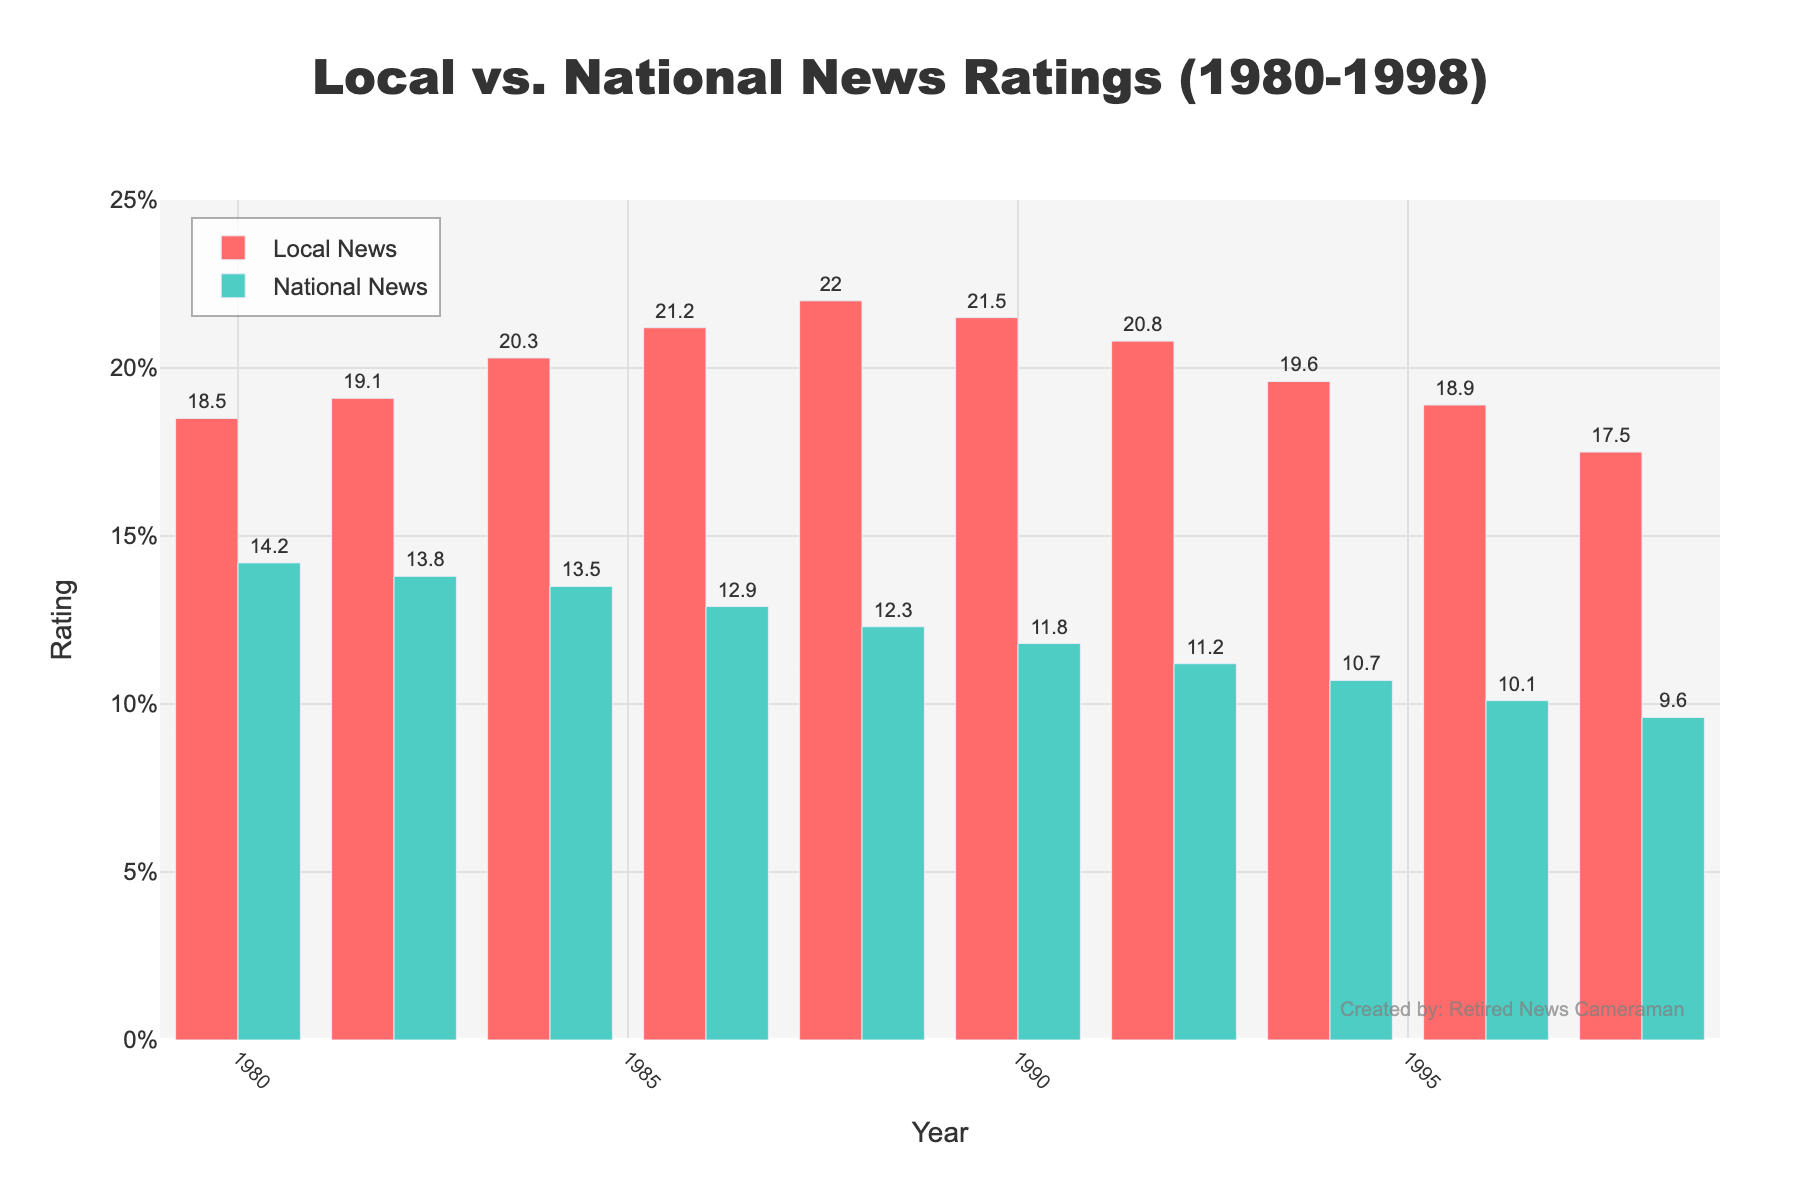What is the average rating of local news from 1980 to 1998? Add up all the local news ratings and divide by the number of years: (18.5 + 19.1 + 20.3 + 21.2 + 22.0 + 21.5 + 20.8 + 19.6 + 18.9 + 17.5) / 10 = 199.4 / 10
Answer: 19.94 Did local news always have higher ratings than national news in every year shown? Compare the local news rating with national news rating for each year. Local news ratings are higher in all years from 1980 to 1998.
Answer: Yes In which year did national news have the lowest rating? Identify the year with the lowest value in the national news ratings column. National news rating was lowest in 1998 with a rating of 9.6.
Answer: 1998 What is the difference in ratings between local and national news in 1988? Subtract the national news rating from the local news rating for 1988: 22.0 - 12.3 = 9.7
Answer: 9.7 In which year was the difference between local and national news ratings the greatest, and what is the value of that difference? Calculate the difference for each year and find the maximum value: 
(1980: 18.5-14.2=4.3), 
(1982: 19.1-13.8=5.3), 
(1984: 20.3-13.5=6.8),
(1986: 21.2-12.9=8.3), 
(1988: 22.0-12.3=9.7), 
(1990: 21.5-11.8=9.7), 
(1992: 20.8-11.2=9.6), 
(1994: 19.6-10.7=8.9), 
(1996: 18.9-10.1=8.8), 
(1998: 17.5-9.6=7.9).
Greatest difference is 9.7 in 1988 and 1990.
Answer: 1988 and 1990, 9.7 Which year saw the highest rating for local news, and what was that rating? Identify the year with the highest local news rating. The highest rating for local news was 22.0 in 1988.
Answer: 1988, 22.0 How did the ratings for national news change from 1980 to 1998? Observe the trend of national news ratings. The ratings for national news consistently decreased from 14.2 in 1980 to 9.6 in 1998.
Answer: Decreased By how much did the local news rating decrease from its peak in 1988 to 1998? Identify the peak (22.0 in 1988) and the rating in 1998, then subtract the 1998 rating from the peak: 22.0 - 17.5 = 4.5.
Answer: 4.5 What color represents the national news ratings? Look at the visual attributes in the chart. National news ratings are represented by green bars.
Answer: Green What is the average rating of national news in the 1980s (1980-1989)? Sum the national news ratings for 1980, 1982, 1984, 1986, and 1988 and divide by 5: (14.2 + 13.8 + 13.5 + 12.9 + 12.3) / 5 = 66.7 / 5
Answer: 13.34 